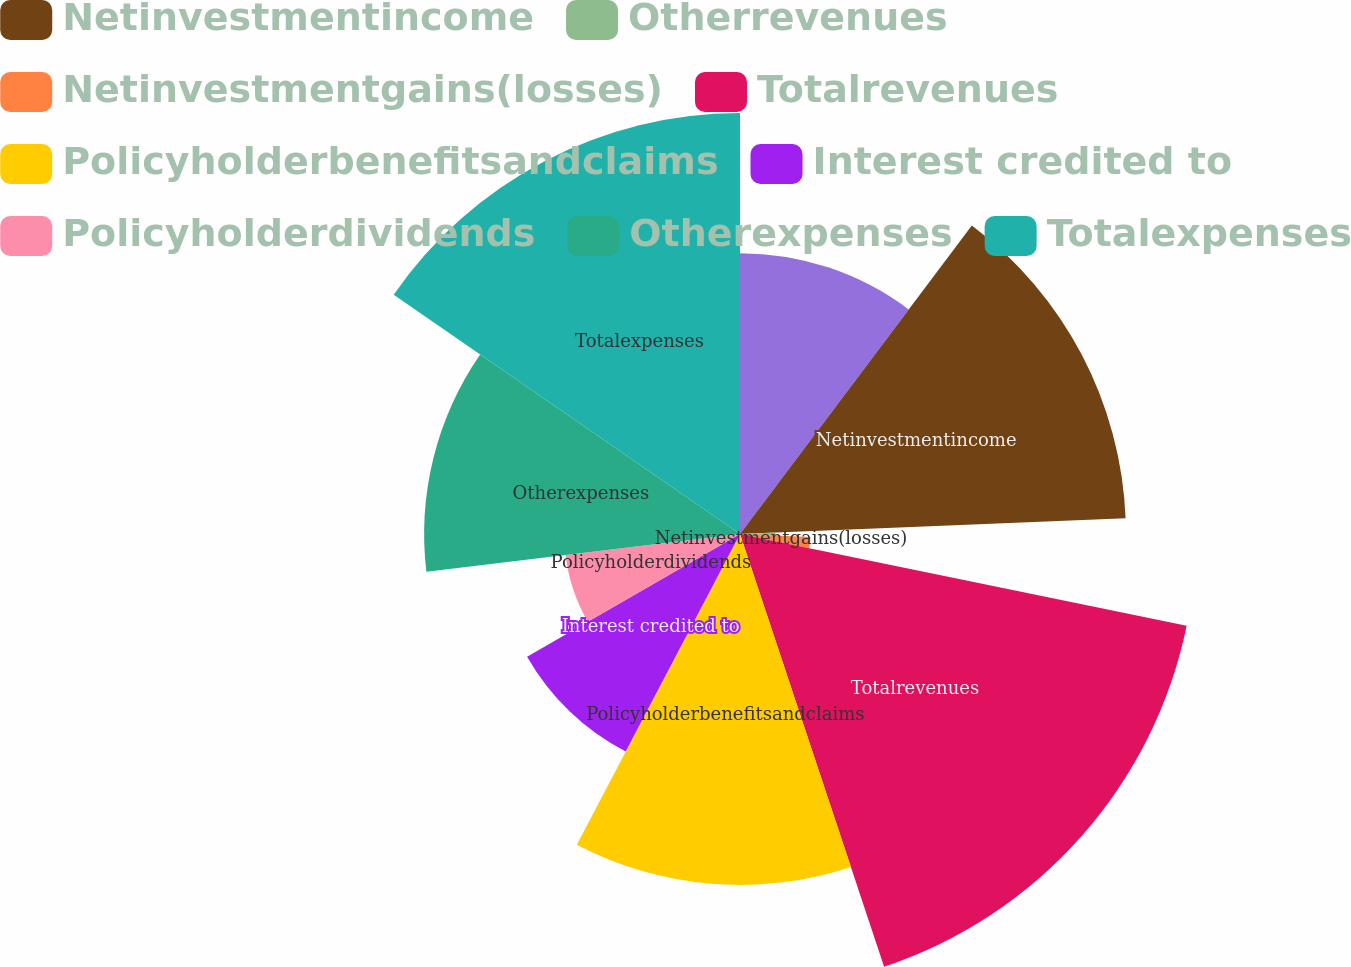<chart> <loc_0><loc_0><loc_500><loc_500><pie_chart><ecel><fcel>Netinvestmentincome<fcel>Otherrevenues<fcel>Netinvestmentgains(losses)<fcel>Totalrevenues<fcel>Policyholderbenefitsandclaims<fcel>Interest credited to<fcel>Policyholderdividends<fcel>Otherexpenses<fcel>Totalexpenses<nl><fcel>10.26%<fcel>14.1%<fcel>1.3%<fcel>2.58%<fcel>16.66%<fcel>12.82%<fcel>8.98%<fcel>6.42%<fcel>11.54%<fcel>15.38%<nl></chart> 